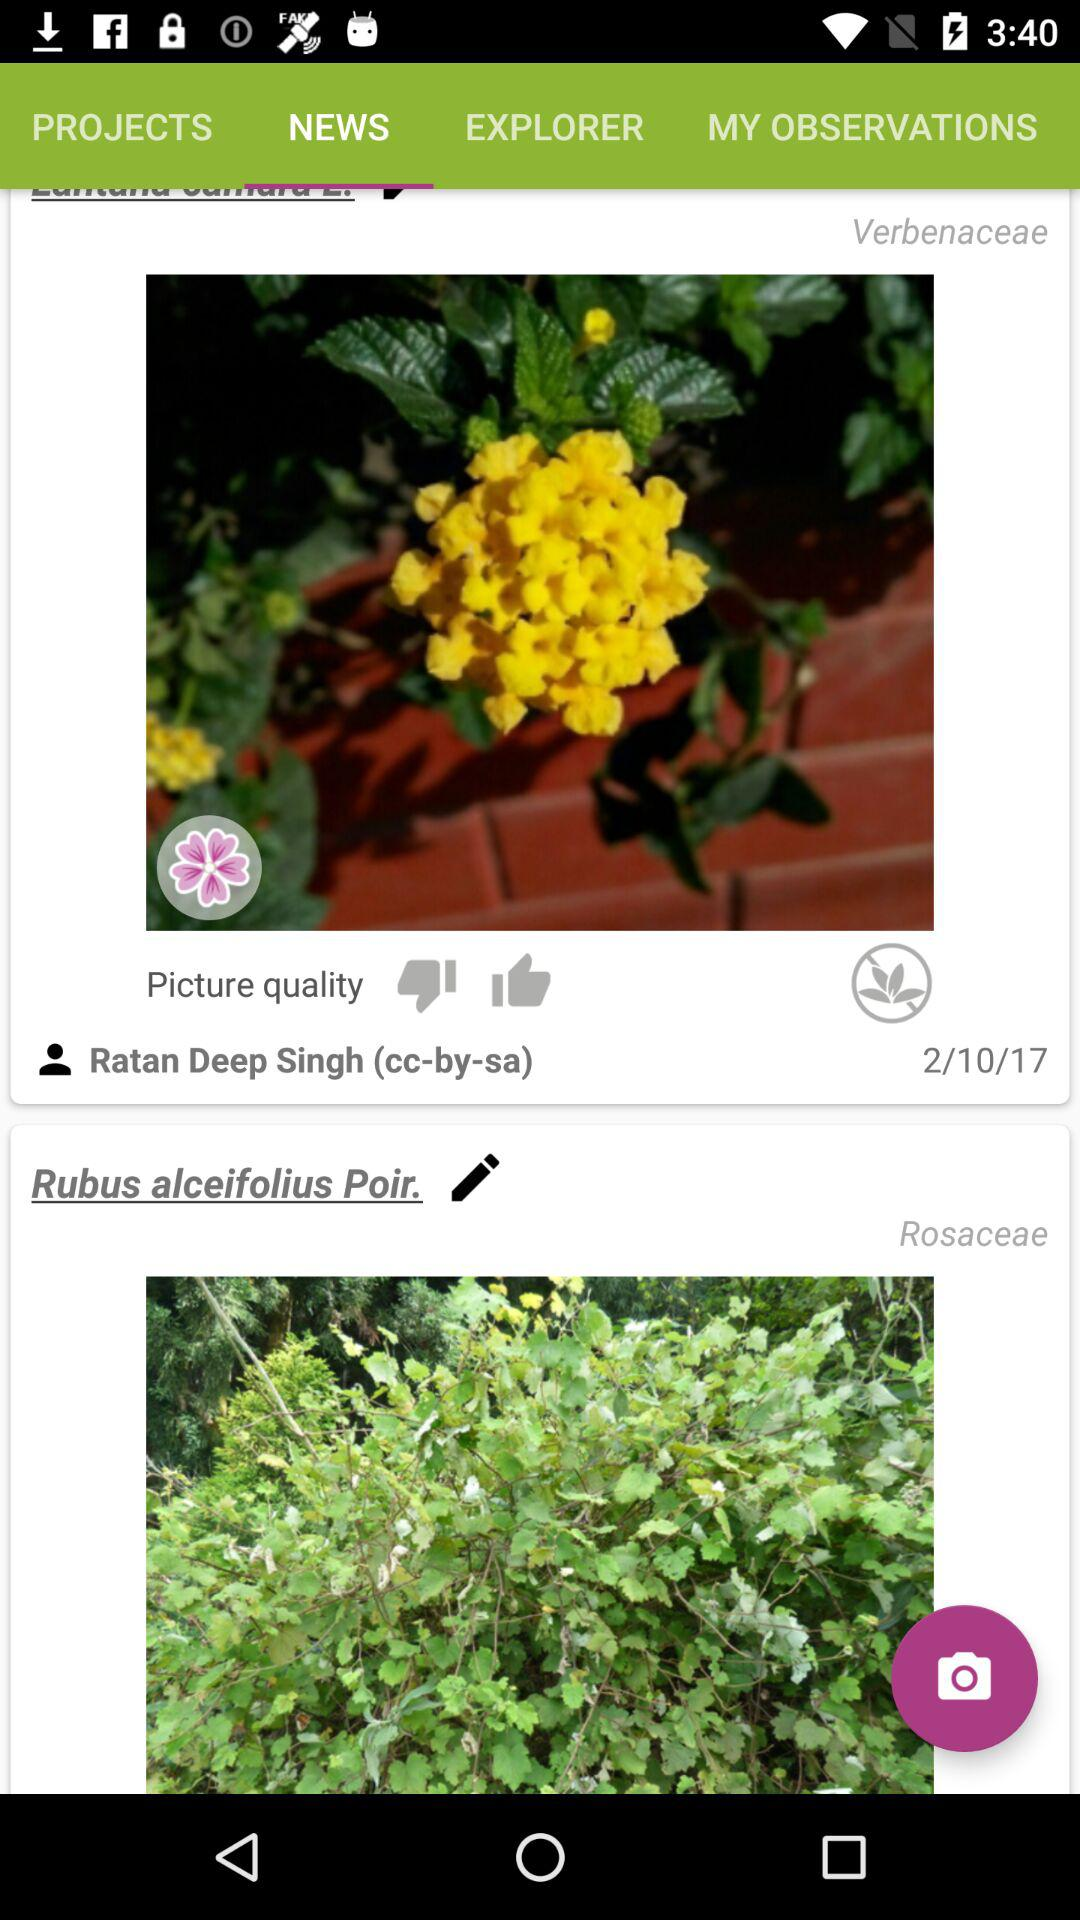What is the colour of the verbenaceae that is visible on the screen?
When the provided information is insufficient, respond with <no answer>. <no answer> 